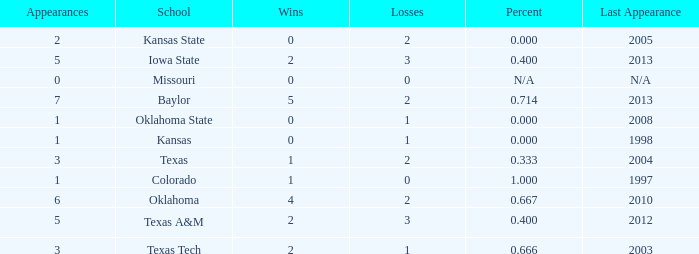How many schools had the win loss ratio of 0.667?  1.0. 